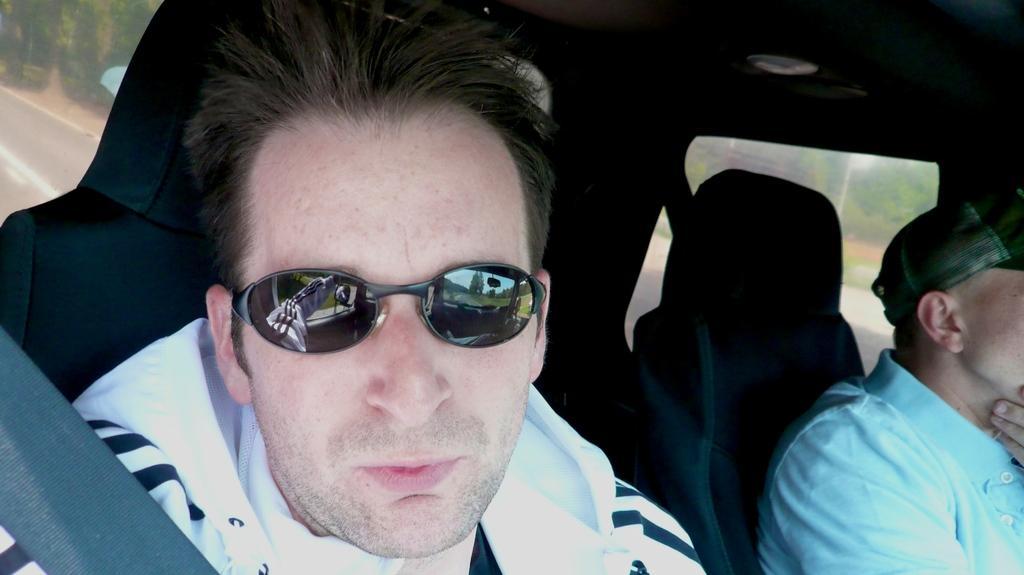Describe this image in one or two sentences. This image is taken inside a car. There is a person sitting in front of the image wearing sunglasses. Beside him there is another person wearing a cap. In the background of the image we can see tree and road. 